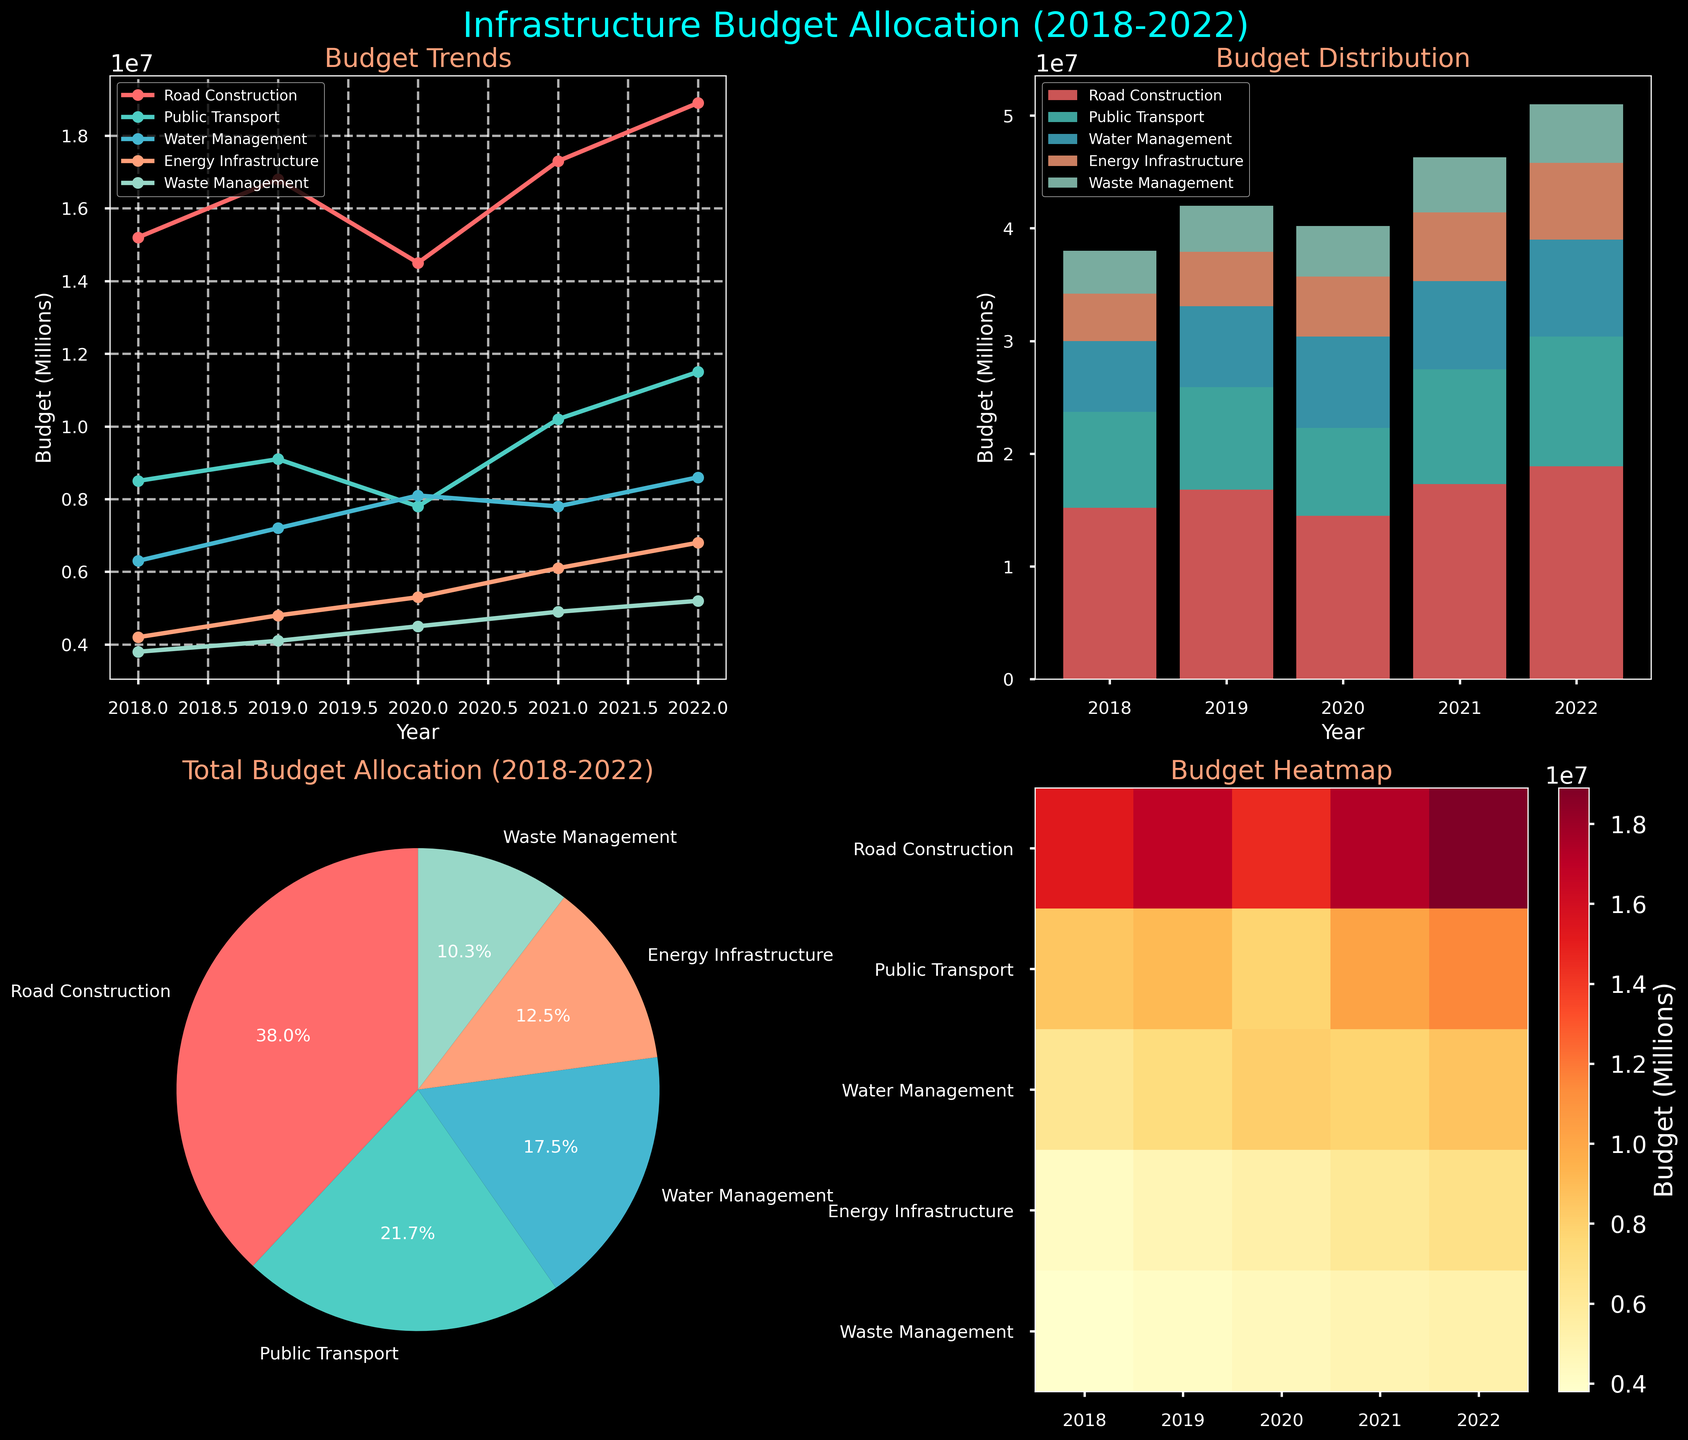What is the title of the line plot in the figure? The title of the line plot can be found at the top of the first subplot, which includes the phrase 'Budget Trends'.
Answer: Budget Trends How many infrastructure project types are represented in the pie chart? Each segment of the pie chart represents a different project type. Counting these segments gives the number of project types.
Answer: 5 Which project type had the highest budget allocation in 2021 according to the line plot? By examining the data points on the line plot for 2021, Road Construction has the highest budget allocation, as indicated by the values on the vertical axis.
Answer: Road Construction What is the trend of Public Transport budget allocation over the years as shown in the line plot? By observing the line corresponding to Public Transport, the budget allocation shows an increasing trend from 2018 to 2022.
Answer: Increasing In the bar plot, which year had the smallest total budget allocation for infrastructure projects? By comparing the total height of the stacked bars for each year, 2020 has the smallest total height, indicating the smallest budget allocation.
Answer: 2020 According to the heatmap, what was the budget for Energy Infrastructure in 2020? By locating the intersection of the row for Energy Infrastructure and the column for 2020, you can find the corresponding budget value.
Answer: 5300000 How does the 2019 Waste Management budget compare to the 2022 Waste Management budget in the bar plot? By comparing the height of the 2019 and 2022 segments for Waste Management in the stacked bar plot, 2022 has a higher segment.
Answer: 2022 is higher What is the average annual budget for Water Management from 2018 to 2022 as indicated in the line plot? Sum the budget values for Water Management from 2018 to 2022 and divide by the number of years. (6300000 + 7200000 + 8100000 + 7800000 + 8600000) / 5 = 7600000
Answer: 7600000 What proportion of the total budget from 2018 to 2022 is allocated to Road Construction according to the pie chart? The segment of the pie chart that corresponds to Road Construction will have a label indicating its percentage of the total budget. According to the sums given in the pie chart, this percentage is 33.4%.
Answer: 33.4% Based on the heatmap, which project shows the most consistent budget across the years? By examining the heatmap's color intensity for each project across different years, Public Transport has the most consistent color shades, indicating a more stable budget.
Answer: Public Transport 